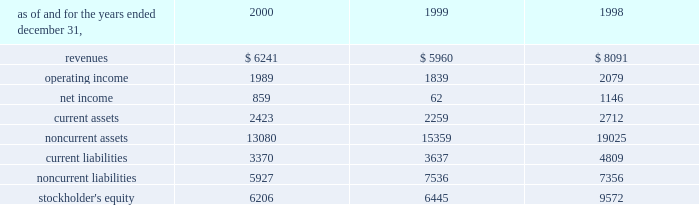A e s 2 0 0 0 f i n a n c i a l r e v i e w in may 2000 , a subsidiary of the company acquired an additional 5% ( 5 % ) of the preferred , non-voting shares of eletropaulo for approximately $ 90 million .
In january 2000 , 59% ( 59 % ) of the preferred non-voting shares were acquired for approximately $ 1 billion at auction from bndes , the national development bank of brazil .
The price established at auction was approximately $ 72.18 per 1000 shares , to be paid in four annual installments com- mencing with a payment of 18.5% ( 18.5 % ) of the total price upon closing of the transaction and installments of 25.9% ( 25.9 % ) , 27.1% ( 27.1 % ) and 28.5% ( 28.5 % ) of the total price to be paid annually thereafter .
At december 31 , 2000 , the company had a total economic interest of 49.6% ( 49.6 % ) in eletropaulo .
The company accounts for this investment using the equity method based on the related consortium agreement that allows the exercise of significant influence .
In august 2000 , a subsidiary of the company acquired a 49% ( 49 % ) interest in songas limited for approxi- mately $ 40 million .
Songas limited owns the songo songo gas-to-electricity project in tanzania .
Under the terms of a project management agreement , the company has assumed overall project management responsibility .
The project consists of the refurbishment and operation of five natural gas wells in coastal tanzania , the construction and operation of a 65 mmscf/day gas processing plant and related facilities , the construction of a 230 km marine and land pipeline from the gas plant to dar es salaam and the conversion and upgrading of an existing 112 mw power station in dar es salaam to burn natural gas , with an optional additional unit to be constructed at the plant .
Since the project is currently under construction , no rev- enues or expenses have been incurred , and therefore no results are shown in the table .
In december 2000 , a subsidiary of the company with edf international s.a .
( 201cedf 201d ) completed the acquisition of an additional 3.5% ( 3.5 % ) interest in light from two sub- sidiaries of reliant energy for approximately $ 136 mil- lion .
Pursuant to the acquisition , the company acquired 30% ( 30 % ) of the shares while edf acquired the remainder .
With the completion of this transaction , the company owns approximately 21.14% ( 21.14 % ) of light .
In december 2000 , a subsidiary of the company entered into an agreement with edf to jointly acquire an additional 9.2% ( 9.2 % ) interest in light , which is held by a sub- sidiary of companhia siderurgica nacional ( 201ccsn 201d ) .
Pursuant to this transaction , the company acquired an additional 2.75% ( 2.75 % ) interest in light for $ 114.6 million .
This transaction closed in january 2001 .
Following the purchase of the light shares previously owned by csn , aes and edf will together be the con- trolling shareholders of light and eletropaulo .
Aes and edf have agreed that aes will eventually take operational control of eletropaulo and the telecom businesses of light and eletropaulo , while edf will eventually take opera- tional control of light and eletropaulo 2019s electric workshop business .
Aes and edf intend to continue to pursue a fur- ther rationalization of their ownership stakes in light and eletropaulo , the result of which aes would become the sole controlling shareholder of eletropaulo and edf would become the sole controlling shareholder of light .
Upon consummation of the transaction , aes will begin consolidating eletropaulo 2019s operating results .
The struc- ture and process by which this rationalization may be effected , and the resulting timing , have yet to be deter- mined and will likely be subject to approval by various brazilian regulatory authorities and other third parties .
As a result , there can be no assurance that this rationalization will take place .
In may 1999 , a subsidiary of the company acquired subscription rights from the brazilian state-controlled eletrobras which allowed it to purchase preferred , non- voting shares in eletropaulo and common shares in light .
The aggregate purchase price of the subscription rights and the underlying shares in light and eletropaulo was approximately $ 53 million and $ 77 million , respectively , and represented 3.7% ( 3.7 % ) and 4.4% ( 4.4 % ) economic ownership interest in their capital stock , respectively .
The table presents summarized financial information ( in millions ) for the company 2019s investments in 50% ( 50 % ) or less owned investments accounted for using the equity method: .

What was the 2000 revenue per dollar of shareholder equity for less than 50% ( 50 % ) owned subsidiaries?\\n? 
Computations: (6241 / 6206)
Answer: 1.00564. 